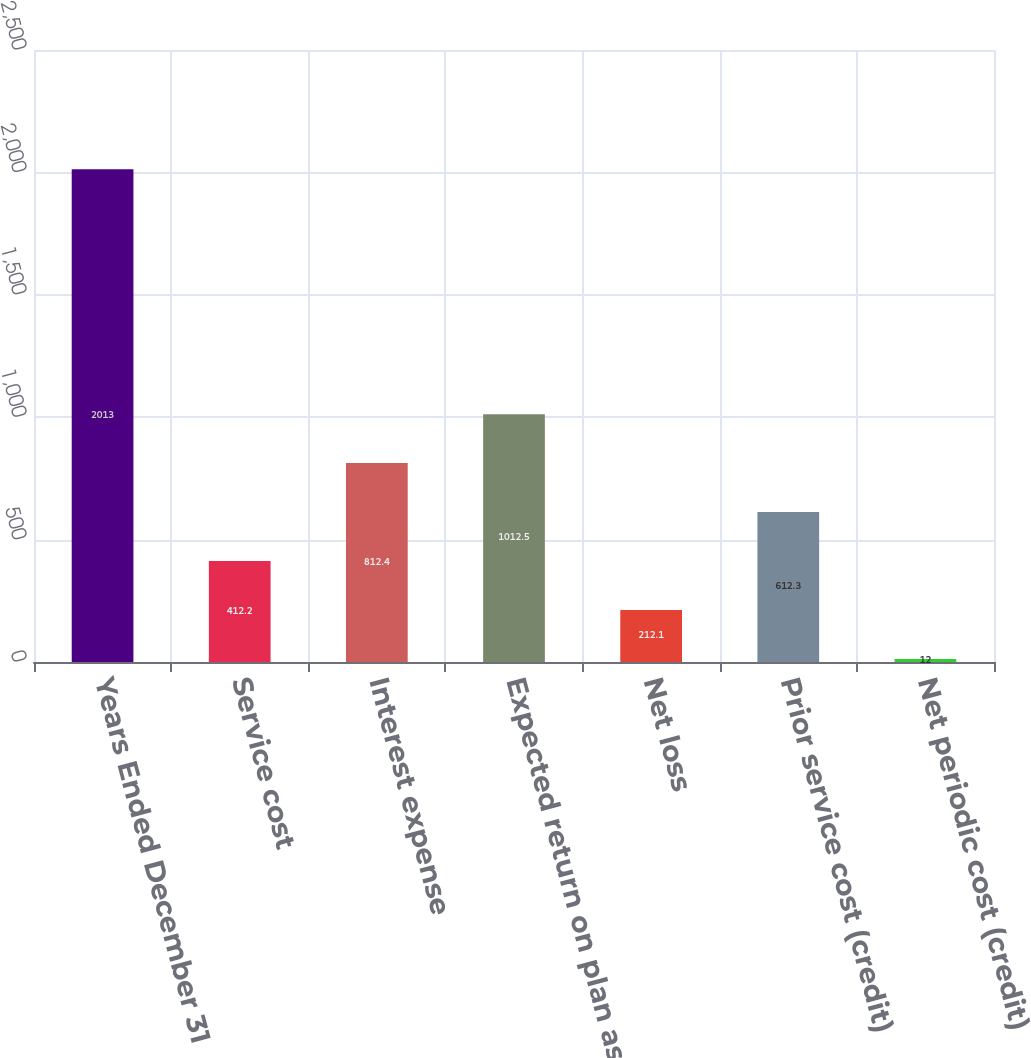Convert chart. <chart><loc_0><loc_0><loc_500><loc_500><bar_chart><fcel>Years Ended December 31<fcel>Service cost<fcel>Interest expense<fcel>Expected return on plan assets<fcel>Net loss<fcel>Prior service cost (credit)<fcel>Net periodic cost (credit)<nl><fcel>2013<fcel>412.2<fcel>812.4<fcel>1012.5<fcel>212.1<fcel>612.3<fcel>12<nl></chart> 